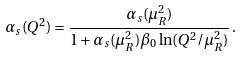<formula> <loc_0><loc_0><loc_500><loc_500>\alpha _ { s } ( Q ^ { 2 } ) = \frac { \alpha _ { s } ( \mu _ { R } ^ { 2 } ) } { 1 + \alpha _ { s } ( \mu _ { R } ^ { 2 } ) \beta _ { 0 } \ln ( Q ^ { 2 } / \mu _ { R } ^ { 2 } ) } \, .</formula> 